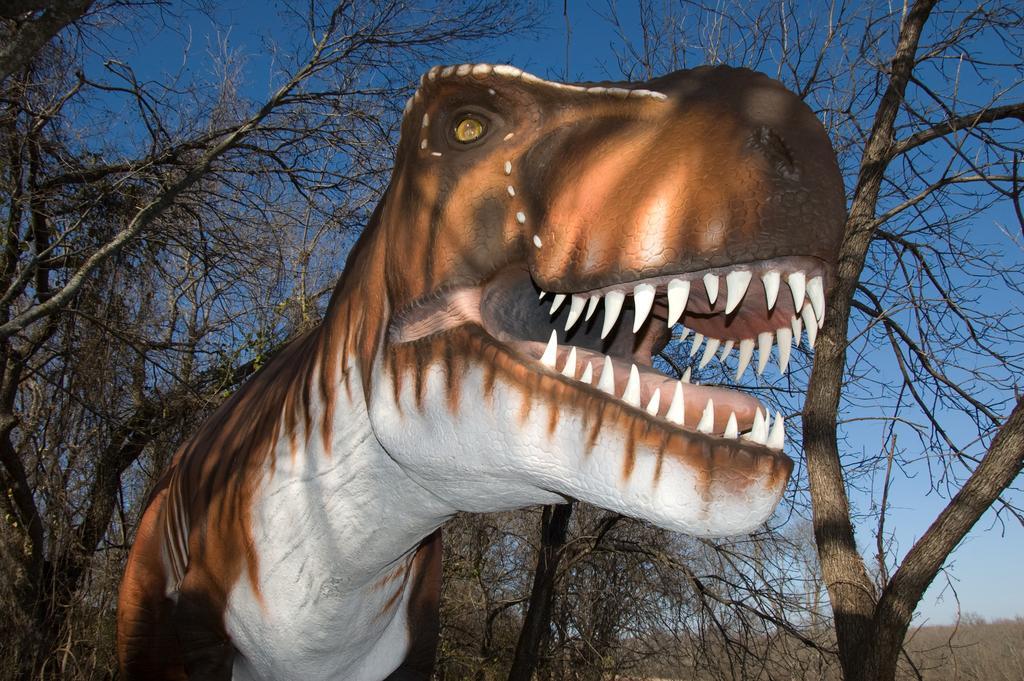How would you summarize this image in a sentence or two? There is a picture of a dinosaur and there are few trees behind it. 